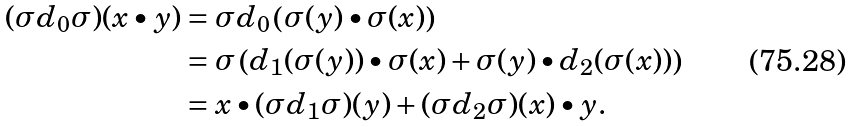Convert formula to latex. <formula><loc_0><loc_0><loc_500><loc_500>( \sigma d _ { 0 } \sigma ) ( x \bullet y ) & = \sigma d _ { 0 } \left ( \sigma ( y ) \bullet \sigma ( x ) \right ) \\ & = \sigma \left ( d _ { 1 } ( \sigma ( y ) ) \bullet \sigma ( x ) + \sigma ( y ) \bullet d _ { 2 } ( \sigma ( x ) ) \right ) \\ & = x \bullet ( \sigma d _ { 1 } \sigma ) ( y ) + ( \sigma d _ { 2 } \sigma ) ( x ) \bullet y .</formula> 